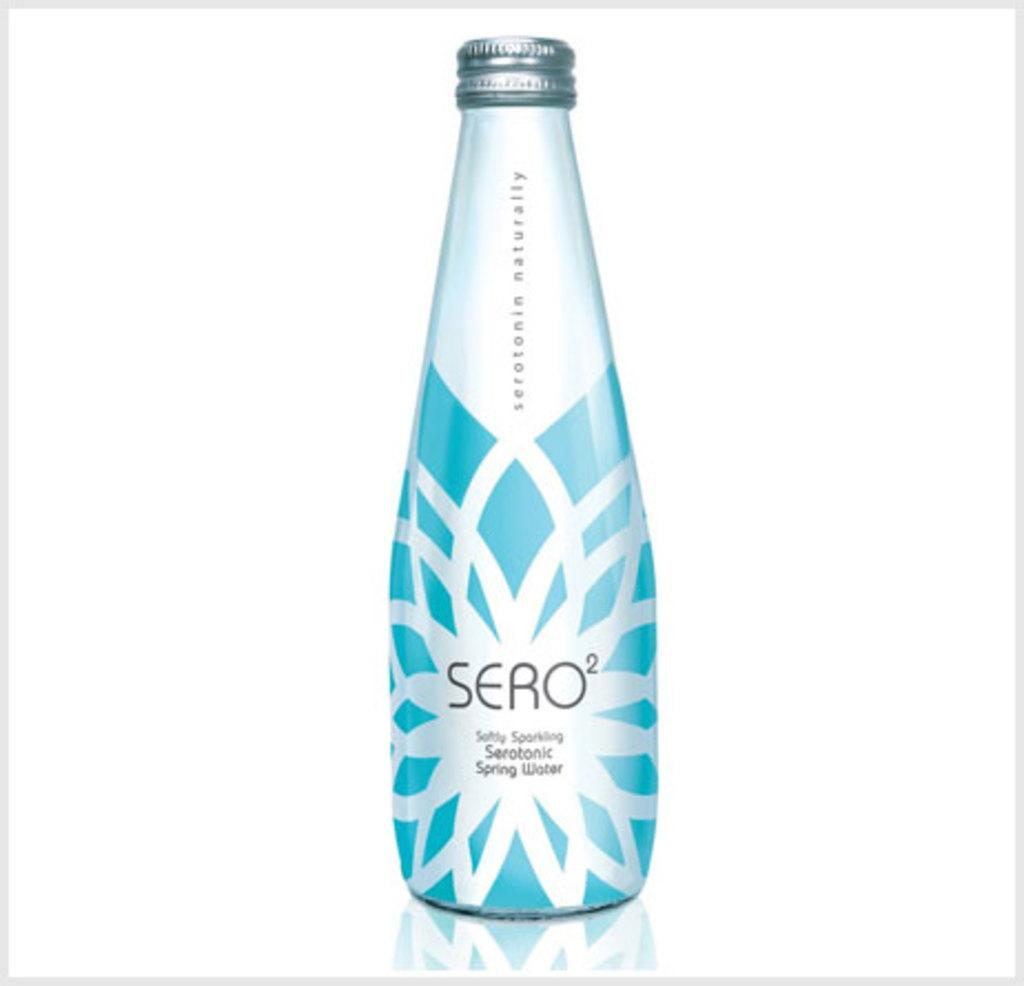Provide a one-sentence caption for the provided image. A bottle of Seratonic Spring Water called Sero2. 